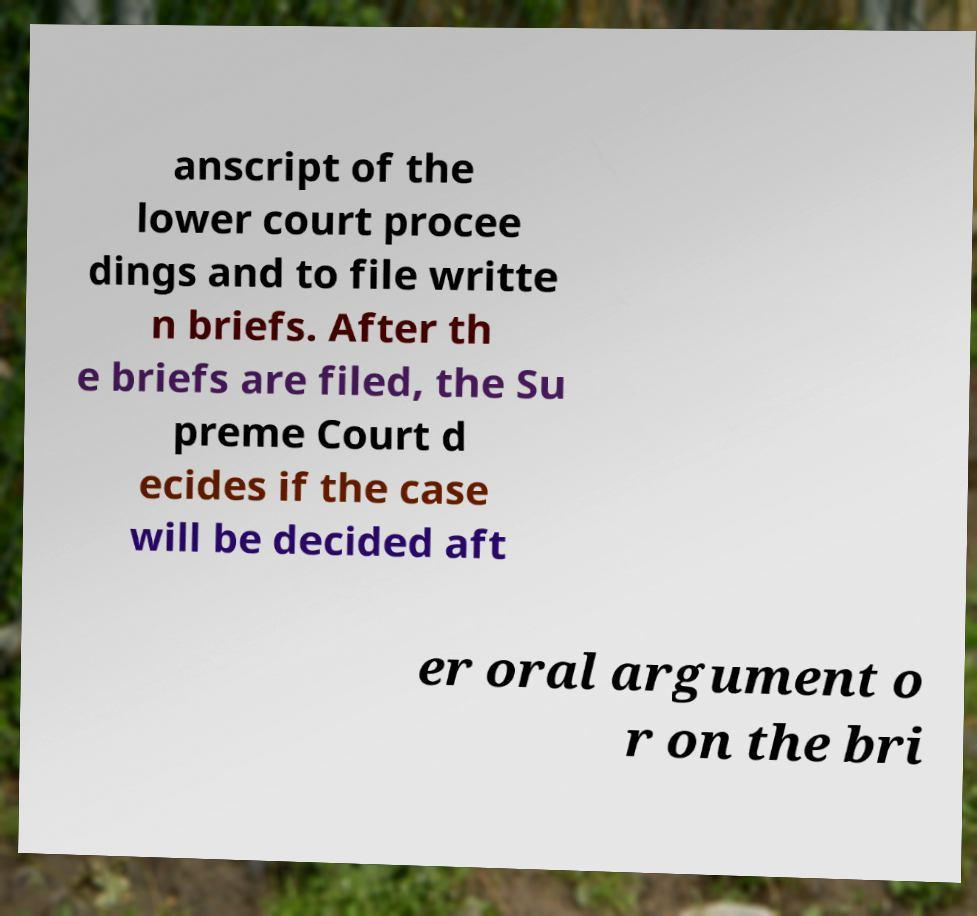Please read and relay the text visible in this image. What does it say? anscript of the lower court procee dings and to file writte n briefs. After th e briefs are filed, the Su preme Court d ecides if the case will be decided aft er oral argument o r on the bri 